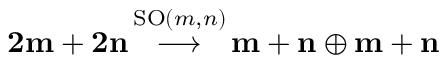<formula> <loc_0><loc_0><loc_500><loc_500>{ 2 m + 2 n } \, { \stackrel { S O ( m , n ) } { \longrightarrow } } \, { m + n } \oplus { m + n }</formula> 